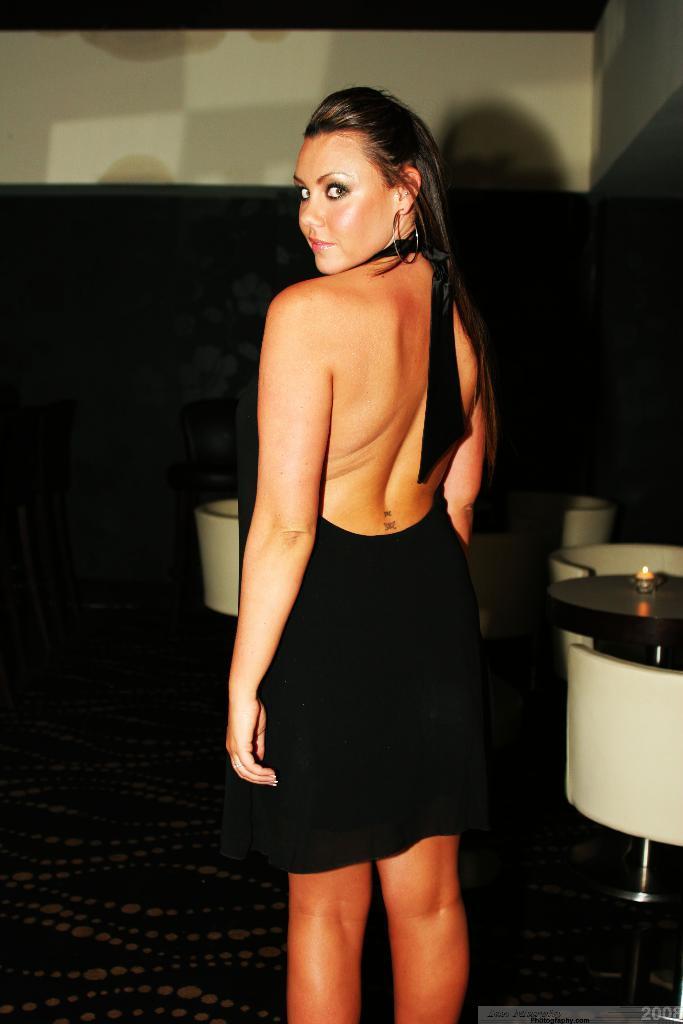Could you give a brief overview of what you see in this image? Here a woman is standing and posing she is wearing a black color dress on the right side of an image there are chairs and a table with a candle. 